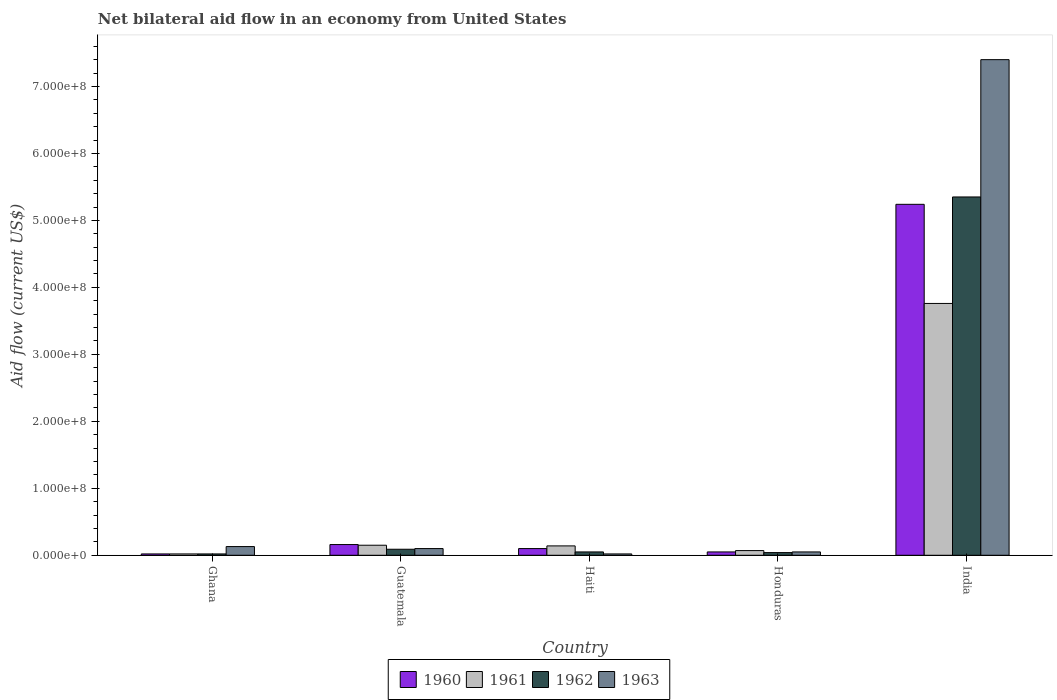How many groups of bars are there?
Offer a very short reply. 5. Are the number of bars per tick equal to the number of legend labels?
Your answer should be very brief. Yes. How many bars are there on the 4th tick from the left?
Your response must be concise. 4. How many bars are there on the 3rd tick from the right?
Provide a short and direct response. 4. What is the label of the 3rd group of bars from the left?
Offer a very short reply. Haiti. In how many cases, is the number of bars for a given country not equal to the number of legend labels?
Your answer should be very brief. 0. What is the net bilateral aid flow in 1960 in India?
Your answer should be compact. 5.24e+08. Across all countries, what is the maximum net bilateral aid flow in 1963?
Ensure brevity in your answer.  7.40e+08. In which country was the net bilateral aid flow in 1963 maximum?
Make the answer very short. India. In which country was the net bilateral aid flow in 1960 minimum?
Ensure brevity in your answer.  Ghana. What is the total net bilateral aid flow in 1962 in the graph?
Ensure brevity in your answer.  5.55e+08. What is the difference between the net bilateral aid flow in 1963 in Guatemala and that in India?
Give a very brief answer. -7.30e+08. What is the difference between the net bilateral aid flow in 1963 in Ghana and the net bilateral aid flow in 1962 in India?
Ensure brevity in your answer.  -5.22e+08. What is the average net bilateral aid flow in 1960 per country?
Offer a very short reply. 1.11e+08. What is the difference between the net bilateral aid flow of/in 1961 and net bilateral aid flow of/in 1963 in Haiti?
Keep it short and to the point. 1.20e+07. In how many countries, is the net bilateral aid flow in 1961 greater than 380000000 US$?
Your answer should be compact. 0. What is the ratio of the net bilateral aid flow in 1961 in Ghana to that in Guatemala?
Make the answer very short. 0.13. What is the difference between the highest and the second highest net bilateral aid flow in 1963?
Give a very brief answer. 7.27e+08. What is the difference between the highest and the lowest net bilateral aid flow in 1961?
Your answer should be very brief. 3.74e+08. In how many countries, is the net bilateral aid flow in 1960 greater than the average net bilateral aid flow in 1960 taken over all countries?
Make the answer very short. 1. Is it the case that in every country, the sum of the net bilateral aid flow in 1961 and net bilateral aid flow in 1962 is greater than the net bilateral aid flow in 1963?
Provide a succinct answer. No. Are all the bars in the graph horizontal?
Give a very brief answer. No. How many countries are there in the graph?
Your response must be concise. 5. What is the difference between two consecutive major ticks on the Y-axis?
Provide a succinct answer. 1.00e+08. Are the values on the major ticks of Y-axis written in scientific E-notation?
Offer a very short reply. Yes. Does the graph contain any zero values?
Offer a terse response. No. Does the graph contain grids?
Provide a short and direct response. No. How many legend labels are there?
Your answer should be compact. 4. What is the title of the graph?
Ensure brevity in your answer.  Net bilateral aid flow in an economy from United States. What is the label or title of the X-axis?
Provide a short and direct response. Country. What is the Aid flow (current US$) in 1960 in Ghana?
Provide a succinct answer. 2.00e+06. What is the Aid flow (current US$) in 1962 in Ghana?
Ensure brevity in your answer.  2.00e+06. What is the Aid flow (current US$) of 1963 in Ghana?
Give a very brief answer. 1.30e+07. What is the Aid flow (current US$) of 1960 in Guatemala?
Ensure brevity in your answer.  1.60e+07. What is the Aid flow (current US$) in 1961 in Guatemala?
Your response must be concise. 1.50e+07. What is the Aid flow (current US$) in 1962 in Guatemala?
Provide a short and direct response. 9.00e+06. What is the Aid flow (current US$) of 1961 in Haiti?
Ensure brevity in your answer.  1.40e+07. What is the Aid flow (current US$) of 1962 in Haiti?
Offer a terse response. 5.00e+06. What is the Aid flow (current US$) of 1963 in Haiti?
Keep it short and to the point. 2.00e+06. What is the Aid flow (current US$) of 1961 in Honduras?
Your response must be concise. 7.00e+06. What is the Aid flow (current US$) of 1962 in Honduras?
Ensure brevity in your answer.  4.00e+06. What is the Aid flow (current US$) of 1963 in Honduras?
Your answer should be very brief. 5.00e+06. What is the Aid flow (current US$) of 1960 in India?
Give a very brief answer. 5.24e+08. What is the Aid flow (current US$) of 1961 in India?
Your answer should be very brief. 3.76e+08. What is the Aid flow (current US$) in 1962 in India?
Make the answer very short. 5.35e+08. What is the Aid flow (current US$) of 1963 in India?
Ensure brevity in your answer.  7.40e+08. Across all countries, what is the maximum Aid flow (current US$) in 1960?
Provide a short and direct response. 5.24e+08. Across all countries, what is the maximum Aid flow (current US$) in 1961?
Provide a succinct answer. 3.76e+08. Across all countries, what is the maximum Aid flow (current US$) in 1962?
Your response must be concise. 5.35e+08. Across all countries, what is the maximum Aid flow (current US$) of 1963?
Provide a short and direct response. 7.40e+08. Across all countries, what is the minimum Aid flow (current US$) in 1960?
Provide a short and direct response. 2.00e+06. Across all countries, what is the minimum Aid flow (current US$) of 1961?
Give a very brief answer. 2.00e+06. Across all countries, what is the minimum Aid flow (current US$) of 1963?
Give a very brief answer. 2.00e+06. What is the total Aid flow (current US$) of 1960 in the graph?
Offer a terse response. 5.57e+08. What is the total Aid flow (current US$) in 1961 in the graph?
Your response must be concise. 4.14e+08. What is the total Aid flow (current US$) in 1962 in the graph?
Keep it short and to the point. 5.55e+08. What is the total Aid flow (current US$) of 1963 in the graph?
Offer a very short reply. 7.70e+08. What is the difference between the Aid flow (current US$) of 1960 in Ghana and that in Guatemala?
Offer a terse response. -1.40e+07. What is the difference between the Aid flow (current US$) in 1961 in Ghana and that in Guatemala?
Make the answer very short. -1.30e+07. What is the difference between the Aid flow (current US$) of 1962 in Ghana and that in Guatemala?
Make the answer very short. -7.00e+06. What is the difference between the Aid flow (current US$) in 1960 in Ghana and that in Haiti?
Your answer should be compact. -8.00e+06. What is the difference between the Aid flow (current US$) of 1961 in Ghana and that in Haiti?
Your response must be concise. -1.20e+07. What is the difference between the Aid flow (current US$) in 1962 in Ghana and that in Haiti?
Offer a very short reply. -3.00e+06. What is the difference between the Aid flow (current US$) of 1963 in Ghana and that in Haiti?
Provide a succinct answer. 1.10e+07. What is the difference between the Aid flow (current US$) of 1961 in Ghana and that in Honduras?
Ensure brevity in your answer.  -5.00e+06. What is the difference between the Aid flow (current US$) of 1962 in Ghana and that in Honduras?
Your answer should be very brief. -2.00e+06. What is the difference between the Aid flow (current US$) of 1960 in Ghana and that in India?
Keep it short and to the point. -5.22e+08. What is the difference between the Aid flow (current US$) in 1961 in Ghana and that in India?
Your response must be concise. -3.74e+08. What is the difference between the Aid flow (current US$) in 1962 in Ghana and that in India?
Your answer should be compact. -5.33e+08. What is the difference between the Aid flow (current US$) in 1963 in Ghana and that in India?
Provide a succinct answer. -7.27e+08. What is the difference between the Aid flow (current US$) of 1960 in Guatemala and that in Honduras?
Your answer should be compact. 1.10e+07. What is the difference between the Aid flow (current US$) of 1961 in Guatemala and that in Honduras?
Keep it short and to the point. 8.00e+06. What is the difference between the Aid flow (current US$) in 1962 in Guatemala and that in Honduras?
Keep it short and to the point. 5.00e+06. What is the difference between the Aid flow (current US$) in 1960 in Guatemala and that in India?
Provide a succinct answer. -5.08e+08. What is the difference between the Aid flow (current US$) of 1961 in Guatemala and that in India?
Provide a short and direct response. -3.61e+08. What is the difference between the Aid flow (current US$) in 1962 in Guatemala and that in India?
Your answer should be compact. -5.26e+08. What is the difference between the Aid flow (current US$) in 1963 in Guatemala and that in India?
Offer a terse response. -7.30e+08. What is the difference between the Aid flow (current US$) of 1960 in Haiti and that in Honduras?
Provide a short and direct response. 5.00e+06. What is the difference between the Aid flow (current US$) in 1962 in Haiti and that in Honduras?
Offer a terse response. 1.00e+06. What is the difference between the Aid flow (current US$) in 1963 in Haiti and that in Honduras?
Offer a very short reply. -3.00e+06. What is the difference between the Aid flow (current US$) in 1960 in Haiti and that in India?
Offer a very short reply. -5.14e+08. What is the difference between the Aid flow (current US$) in 1961 in Haiti and that in India?
Ensure brevity in your answer.  -3.62e+08. What is the difference between the Aid flow (current US$) of 1962 in Haiti and that in India?
Offer a very short reply. -5.30e+08. What is the difference between the Aid flow (current US$) in 1963 in Haiti and that in India?
Provide a short and direct response. -7.38e+08. What is the difference between the Aid flow (current US$) in 1960 in Honduras and that in India?
Provide a succinct answer. -5.19e+08. What is the difference between the Aid flow (current US$) of 1961 in Honduras and that in India?
Provide a short and direct response. -3.69e+08. What is the difference between the Aid flow (current US$) in 1962 in Honduras and that in India?
Provide a short and direct response. -5.31e+08. What is the difference between the Aid flow (current US$) in 1963 in Honduras and that in India?
Offer a terse response. -7.35e+08. What is the difference between the Aid flow (current US$) of 1960 in Ghana and the Aid flow (current US$) of 1961 in Guatemala?
Your answer should be very brief. -1.30e+07. What is the difference between the Aid flow (current US$) in 1960 in Ghana and the Aid flow (current US$) in 1962 in Guatemala?
Provide a succinct answer. -7.00e+06. What is the difference between the Aid flow (current US$) in 1960 in Ghana and the Aid flow (current US$) in 1963 in Guatemala?
Make the answer very short. -8.00e+06. What is the difference between the Aid flow (current US$) in 1961 in Ghana and the Aid flow (current US$) in 1962 in Guatemala?
Make the answer very short. -7.00e+06. What is the difference between the Aid flow (current US$) in 1961 in Ghana and the Aid flow (current US$) in 1963 in Guatemala?
Give a very brief answer. -8.00e+06. What is the difference between the Aid flow (current US$) of 1962 in Ghana and the Aid flow (current US$) of 1963 in Guatemala?
Make the answer very short. -8.00e+06. What is the difference between the Aid flow (current US$) of 1960 in Ghana and the Aid flow (current US$) of 1961 in Haiti?
Provide a succinct answer. -1.20e+07. What is the difference between the Aid flow (current US$) in 1960 in Ghana and the Aid flow (current US$) in 1963 in Haiti?
Your response must be concise. 0. What is the difference between the Aid flow (current US$) of 1961 in Ghana and the Aid flow (current US$) of 1963 in Haiti?
Provide a succinct answer. 0. What is the difference between the Aid flow (current US$) of 1960 in Ghana and the Aid flow (current US$) of 1961 in Honduras?
Keep it short and to the point. -5.00e+06. What is the difference between the Aid flow (current US$) in 1960 in Ghana and the Aid flow (current US$) in 1962 in Honduras?
Your response must be concise. -2.00e+06. What is the difference between the Aid flow (current US$) of 1960 in Ghana and the Aid flow (current US$) of 1963 in Honduras?
Provide a succinct answer. -3.00e+06. What is the difference between the Aid flow (current US$) of 1961 in Ghana and the Aid flow (current US$) of 1962 in Honduras?
Give a very brief answer. -2.00e+06. What is the difference between the Aid flow (current US$) of 1961 in Ghana and the Aid flow (current US$) of 1963 in Honduras?
Provide a short and direct response. -3.00e+06. What is the difference between the Aid flow (current US$) of 1960 in Ghana and the Aid flow (current US$) of 1961 in India?
Provide a succinct answer. -3.74e+08. What is the difference between the Aid flow (current US$) of 1960 in Ghana and the Aid flow (current US$) of 1962 in India?
Your response must be concise. -5.33e+08. What is the difference between the Aid flow (current US$) in 1960 in Ghana and the Aid flow (current US$) in 1963 in India?
Ensure brevity in your answer.  -7.38e+08. What is the difference between the Aid flow (current US$) of 1961 in Ghana and the Aid flow (current US$) of 1962 in India?
Your response must be concise. -5.33e+08. What is the difference between the Aid flow (current US$) of 1961 in Ghana and the Aid flow (current US$) of 1963 in India?
Make the answer very short. -7.38e+08. What is the difference between the Aid flow (current US$) in 1962 in Ghana and the Aid flow (current US$) in 1963 in India?
Give a very brief answer. -7.38e+08. What is the difference between the Aid flow (current US$) in 1960 in Guatemala and the Aid flow (current US$) in 1961 in Haiti?
Offer a very short reply. 2.00e+06. What is the difference between the Aid flow (current US$) of 1960 in Guatemala and the Aid flow (current US$) of 1962 in Haiti?
Your answer should be very brief. 1.10e+07. What is the difference between the Aid flow (current US$) of 1960 in Guatemala and the Aid flow (current US$) of 1963 in Haiti?
Your answer should be compact. 1.40e+07. What is the difference between the Aid flow (current US$) in 1961 in Guatemala and the Aid flow (current US$) in 1962 in Haiti?
Your response must be concise. 1.00e+07. What is the difference between the Aid flow (current US$) in 1961 in Guatemala and the Aid flow (current US$) in 1963 in Haiti?
Provide a short and direct response. 1.30e+07. What is the difference between the Aid flow (current US$) in 1960 in Guatemala and the Aid flow (current US$) in 1961 in Honduras?
Offer a very short reply. 9.00e+06. What is the difference between the Aid flow (current US$) in 1960 in Guatemala and the Aid flow (current US$) in 1963 in Honduras?
Make the answer very short. 1.10e+07. What is the difference between the Aid flow (current US$) in 1961 in Guatemala and the Aid flow (current US$) in 1962 in Honduras?
Offer a terse response. 1.10e+07. What is the difference between the Aid flow (current US$) of 1961 in Guatemala and the Aid flow (current US$) of 1963 in Honduras?
Your response must be concise. 1.00e+07. What is the difference between the Aid flow (current US$) in 1960 in Guatemala and the Aid flow (current US$) in 1961 in India?
Make the answer very short. -3.60e+08. What is the difference between the Aid flow (current US$) of 1960 in Guatemala and the Aid flow (current US$) of 1962 in India?
Make the answer very short. -5.19e+08. What is the difference between the Aid flow (current US$) of 1960 in Guatemala and the Aid flow (current US$) of 1963 in India?
Offer a terse response. -7.24e+08. What is the difference between the Aid flow (current US$) in 1961 in Guatemala and the Aid flow (current US$) in 1962 in India?
Keep it short and to the point. -5.20e+08. What is the difference between the Aid flow (current US$) in 1961 in Guatemala and the Aid flow (current US$) in 1963 in India?
Your answer should be very brief. -7.25e+08. What is the difference between the Aid flow (current US$) of 1962 in Guatemala and the Aid flow (current US$) of 1963 in India?
Your answer should be very brief. -7.31e+08. What is the difference between the Aid flow (current US$) in 1961 in Haiti and the Aid flow (current US$) in 1963 in Honduras?
Your answer should be very brief. 9.00e+06. What is the difference between the Aid flow (current US$) in 1962 in Haiti and the Aid flow (current US$) in 1963 in Honduras?
Your response must be concise. 0. What is the difference between the Aid flow (current US$) in 1960 in Haiti and the Aid flow (current US$) in 1961 in India?
Your answer should be compact. -3.66e+08. What is the difference between the Aid flow (current US$) in 1960 in Haiti and the Aid flow (current US$) in 1962 in India?
Offer a terse response. -5.25e+08. What is the difference between the Aid flow (current US$) in 1960 in Haiti and the Aid flow (current US$) in 1963 in India?
Your answer should be compact. -7.30e+08. What is the difference between the Aid flow (current US$) of 1961 in Haiti and the Aid flow (current US$) of 1962 in India?
Your answer should be compact. -5.21e+08. What is the difference between the Aid flow (current US$) of 1961 in Haiti and the Aid flow (current US$) of 1963 in India?
Offer a terse response. -7.26e+08. What is the difference between the Aid flow (current US$) of 1962 in Haiti and the Aid flow (current US$) of 1963 in India?
Make the answer very short. -7.35e+08. What is the difference between the Aid flow (current US$) of 1960 in Honduras and the Aid flow (current US$) of 1961 in India?
Keep it short and to the point. -3.71e+08. What is the difference between the Aid flow (current US$) of 1960 in Honduras and the Aid flow (current US$) of 1962 in India?
Keep it short and to the point. -5.30e+08. What is the difference between the Aid flow (current US$) of 1960 in Honduras and the Aid flow (current US$) of 1963 in India?
Give a very brief answer. -7.35e+08. What is the difference between the Aid flow (current US$) in 1961 in Honduras and the Aid flow (current US$) in 1962 in India?
Your answer should be compact. -5.28e+08. What is the difference between the Aid flow (current US$) of 1961 in Honduras and the Aid flow (current US$) of 1963 in India?
Provide a succinct answer. -7.33e+08. What is the difference between the Aid flow (current US$) in 1962 in Honduras and the Aid flow (current US$) in 1963 in India?
Your answer should be very brief. -7.36e+08. What is the average Aid flow (current US$) of 1960 per country?
Give a very brief answer. 1.11e+08. What is the average Aid flow (current US$) of 1961 per country?
Provide a succinct answer. 8.28e+07. What is the average Aid flow (current US$) of 1962 per country?
Offer a very short reply. 1.11e+08. What is the average Aid flow (current US$) of 1963 per country?
Ensure brevity in your answer.  1.54e+08. What is the difference between the Aid flow (current US$) in 1960 and Aid flow (current US$) in 1961 in Ghana?
Offer a very short reply. 0. What is the difference between the Aid flow (current US$) in 1960 and Aid flow (current US$) in 1963 in Ghana?
Give a very brief answer. -1.10e+07. What is the difference between the Aid flow (current US$) of 1961 and Aid flow (current US$) of 1962 in Ghana?
Provide a succinct answer. 0. What is the difference between the Aid flow (current US$) in 1961 and Aid flow (current US$) in 1963 in Ghana?
Your response must be concise. -1.10e+07. What is the difference between the Aid flow (current US$) in 1962 and Aid flow (current US$) in 1963 in Ghana?
Provide a succinct answer. -1.10e+07. What is the difference between the Aid flow (current US$) of 1960 and Aid flow (current US$) of 1963 in Guatemala?
Offer a very short reply. 6.00e+06. What is the difference between the Aid flow (current US$) of 1962 and Aid flow (current US$) of 1963 in Guatemala?
Offer a very short reply. -1.00e+06. What is the difference between the Aid flow (current US$) of 1960 and Aid flow (current US$) of 1963 in Haiti?
Ensure brevity in your answer.  8.00e+06. What is the difference between the Aid flow (current US$) in 1961 and Aid flow (current US$) in 1962 in Haiti?
Your answer should be very brief. 9.00e+06. What is the difference between the Aid flow (current US$) of 1961 and Aid flow (current US$) of 1963 in Haiti?
Your answer should be compact. 1.20e+07. What is the difference between the Aid flow (current US$) in 1960 and Aid flow (current US$) in 1962 in Honduras?
Offer a terse response. 1.00e+06. What is the difference between the Aid flow (current US$) of 1960 and Aid flow (current US$) of 1963 in Honduras?
Your answer should be very brief. 0. What is the difference between the Aid flow (current US$) in 1961 and Aid flow (current US$) in 1962 in Honduras?
Your answer should be very brief. 3.00e+06. What is the difference between the Aid flow (current US$) in 1960 and Aid flow (current US$) in 1961 in India?
Your answer should be compact. 1.48e+08. What is the difference between the Aid flow (current US$) in 1960 and Aid flow (current US$) in 1962 in India?
Offer a very short reply. -1.10e+07. What is the difference between the Aid flow (current US$) of 1960 and Aid flow (current US$) of 1963 in India?
Keep it short and to the point. -2.16e+08. What is the difference between the Aid flow (current US$) of 1961 and Aid flow (current US$) of 1962 in India?
Give a very brief answer. -1.59e+08. What is the difference between the Aid flow (current US$) of 1961 and Aid flow (current US$) of 1963 in India?
Offer a terse response. -3.64e+08. What is the difference between the Aid flow (current US$) of 1962 and Aid flow (current US$) of 1963 in India?
Give a very brief answer. -2.05e+08. What is the ratio of the Aid flow (current US$) in 1961 in Ghana to that in Guatemala?
Your answer should be compact. 0.13. What is the ratio of the Aid flow (current US$) of 1962 in Ghana to that in Guatemala?
Your answer should be very brief. 0.22. What is the ratio of the Aid flow (current US$) of 1961 in Ghana to that in Haiti?
Ensure brevity in your answer.  0.14. What is the ratio of the Aid flow (current US$) of 1960 in Ghana to that in Honduras?
Your response must be concise. 0.4. What is the ratio of the Aid flow (current US$) of 1961 in Ghana to that in Honduras?
Your answer should be very brief. 0.29. What is the ratio of the Aid flow (current US$) of 1962 in Ghana to that in Honduras?
Provide a short and direct response. 0.5. What is the ratio of the Aid flow (current US$) of 1963 in Ghana to that in Honduras?
Your response must be concise. 2.6. What is the ratio of the Aid flow (current US$) in 1960 in Ghana to that in India?
Ensure brevity in your answer.  0. What is the ratio of the Aid flow (current US$) in 1961 in Ghana to that in India?
Make the answer very short. 0.01. What is the ratio of the Aid flow (current US$) in 1962 in Ghana to that in India?
Make the answer very short. 0. What is the ratio of the Aid flow (current US$) of 1963 in Ghana to that in India?
Keep it short and to the point. 0.02. What is the ratio of the Aid flow (current US$) of 1961 in Guatemala to that in Haiti?
Ensure brevity in your answer.  1.07. What is the ratio of the Aid flow (current US$) in 1963 in Guatemala to that in Haiti?
Keep it short and to the point. 5. What is the ratio of the Aid flow (current US$) of 1960 in Guatemala to that in Honduras?
Provide a succinct answer. 3.2. What is the ratio of the Aid flow (current US$) in 1961 in Guatemala to that in Honduras?
Give a very brief answer. 2.14. What is the ratio of the Aid flow (current US$) of 1962 in Guatemala to that in Honduras?
Offer a very short reply. 2.25. What is the ratio of the Aid flow (current US$) of 1963 in Guatemala to that in Honduras?
Provide a short and direct response. 2. What is the ratio of the Aid flow (current US$) in 1960 in Guatemala to that in India?
Your answer should be compact. 0.03. What is the ratio of the Aid flow (current US$) in 1961 in Guatemala to that in India?
Your response must be concise. 0.04. What is the ratio of the Aid flow (current US$) in 1962 in Guatemala to that in India?
Your response must be concise. 0.02. What is the ratio of the Aid flow (current US$) of 1963 in Guatemala to that in India?
Offer a very short reply. 0.01. What is the ratio of the Aid flow (current US$) of 1961 in Haiti to that in Honduras?
Offer a terse response. 2. What is the ratio of the Aid flow (current US$) of 1962 in Haiti to that in Honduras?
Your answer should be compact. 1.25. What is the ratio of the Aid flow (current US$) in 1960 in Haiti to that in India?
Offer a terse response. 0.02. What is the ratio of the Aid flow (current US$) of 1961 in Haiti to that in India?
Give a very brief answer. 0.04. What is the ratio of the Aid flow (current US$) in 1962 in Haiti to that in India?
Your response must be concise. 0.01. What is the ratio of the Aid flow (current US$) of 1963 in Haiti to that in India?
Provide a succinct answer. 0. What is the ratio of the Aid flow (current US$) of 1960 in Honduras to that in India?
Provide a short and direct response. 0.01. What is the ratio of the Aid flow (current US$) in 1961 in Honduras to that in India?
Offer a terse response. 0.02. What is the ratio of the Aid flow (current US$) of 1962 in Honduras to that in India?
Give a very brief answer. 0.01. What is the ratio of the Aid flow (current US$) of 1963 in Honduras to that in India?
Your answer should be compact. 0.01. What is the difference between the highest and the second highest Aid flow (current US$) of 1960?
Make the answer very short. 5.08e+08. What is the difference between the highest and the second highest Aid flow (current US$) in 1961?
Make the answer very short. 3.61e+08. What is the difference between the highest and the second highest Aid flow (current US$) in 1962?
Offer a very short reply. 5.26e+08. What is the difference between the highest and the second highest Aid flow (current US$) in 1963?
Your answer should be compact. 7.27e+08. What is the difference between the highest and the lowest Aid flow (current US$) in 1960?
Provide a succinct answer. 5.22e+08. What is the difference between the highest and the lowest Aid flow (current US$) in 1961?
Your response must be concise. 3.74e+08. What is the difference between the highest and the lowest Aid flow (current US$) of 1962?
Your response must be concise. 5.33e+08. What is the difference between the highest and the lowest Aid flow (current US$) in 1963?
Offer a terse response. 7.38e+08. 